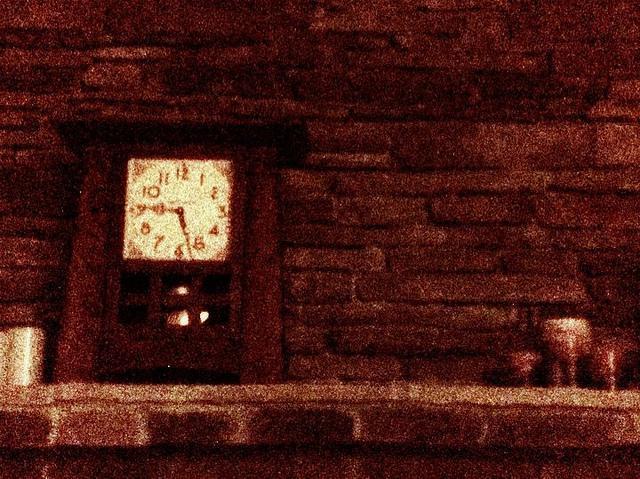How many cups can you see?
Give a very brief answer. 2. How many dogs are there?
Give a very brief answer. 0. 